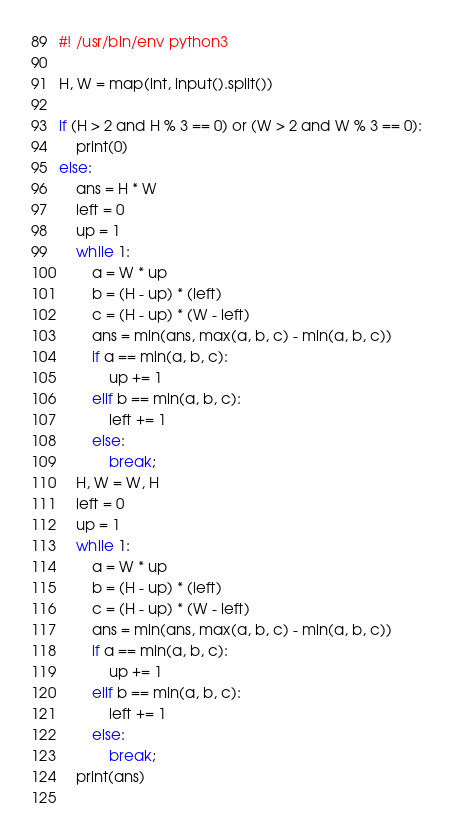<code> <loc_0><loc_0><loc_500><loc_500><_Python_>#! /usr/bin/env python3

H, W = map(int, input().split())

if (H > 2 and H % 3 == 0) or (W > 2 and W % 3 == 0):
    print(0)
else:
    ans = H * W
    left = 0
    up = 1
    while 1:
        a = W * up
        b = (H - up) * (left)
        c = (H - up) * (W - left)
        ans = min(ans, max(a, b, c) - min(a, b, c))
        if a == min(a, b, c):
            up += 1
        elif b == min(a, b, c):
            left += 1
        else:
            break;
    H, W = W, H
    left = 0
    up = 1
    while 1:
        a = W * up
        b = (H - up) * (left)
        c = (H - up) * (W - left)
        ans = min(ans, max(a, b, c) - min(a, b, c))
        if a == min(a, b, c):
            up += 1
        elif b == min(a, b, c):
            left += 1
        else:
            break;
    print(ans)
        </code> 